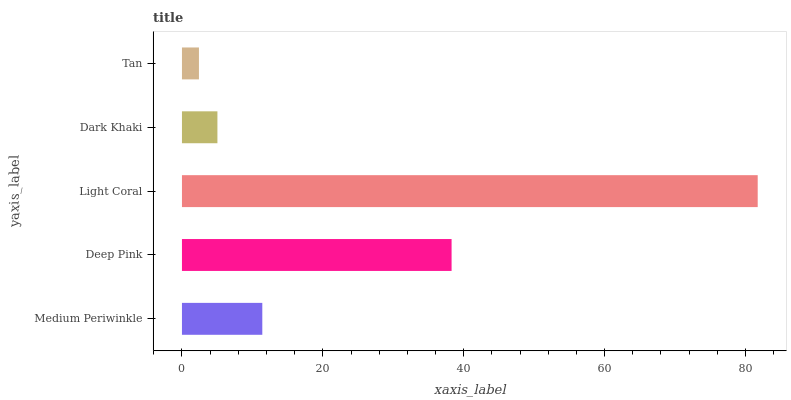Is Tan the minimum?
Answer yes or no. Yes. Is Light Coral the maximum?
Answer yes or no. Yes. Is Deep Pink the minimum?
Answer yes or no. No. Is Deep Pink the maximum?
Answer yes or no. No. Is Deep Pink greater than Medium Periwinkle?
Answer yes or no. Yes. Is Medium Periwinkle less than Deep Pink?
Answer yes or no. Yes. Is Medium Periwinkle greater than Deep Pink?
Answer yes or no. No. Is Deep Pink less than Medium Periwinkle?
Answer yes or no. No. Is Medium Periwinkle the high median?
Answer yes or no. Yes. Is Medium Periwinkle the low median?
Answer yes or no. Yes. Is Tan the high median?
Answer yes or no. No. Is Tan the low median?
Answer yes or no. No. 